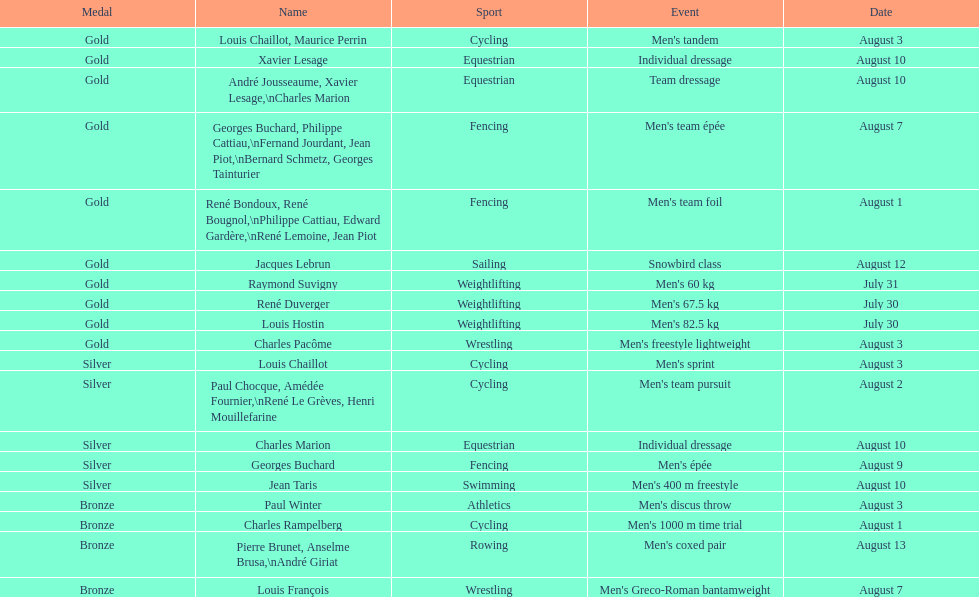Did gold medals surpass silver medals in quantity? Yes. 